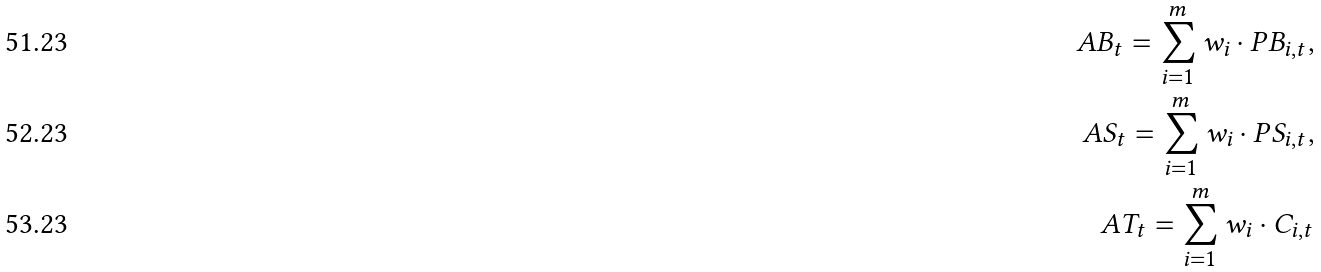Convert formula to latex. <formula><loc_0><loc_0><loc_500><loc_500>A B _ { t } = \sum _ { i = 1 } ^ { m } w _ { i } \cdot P B _ { i , t } , \\ A S _ { t } = \sum _ { i = 1 } ^ { m } w _ { i } \cdot P S _ { i , t } , \\ A T _ { t } = \sum _ { i = 1 } ^ { m } w _ { i } \cdot C _ { i , t }</formula> 